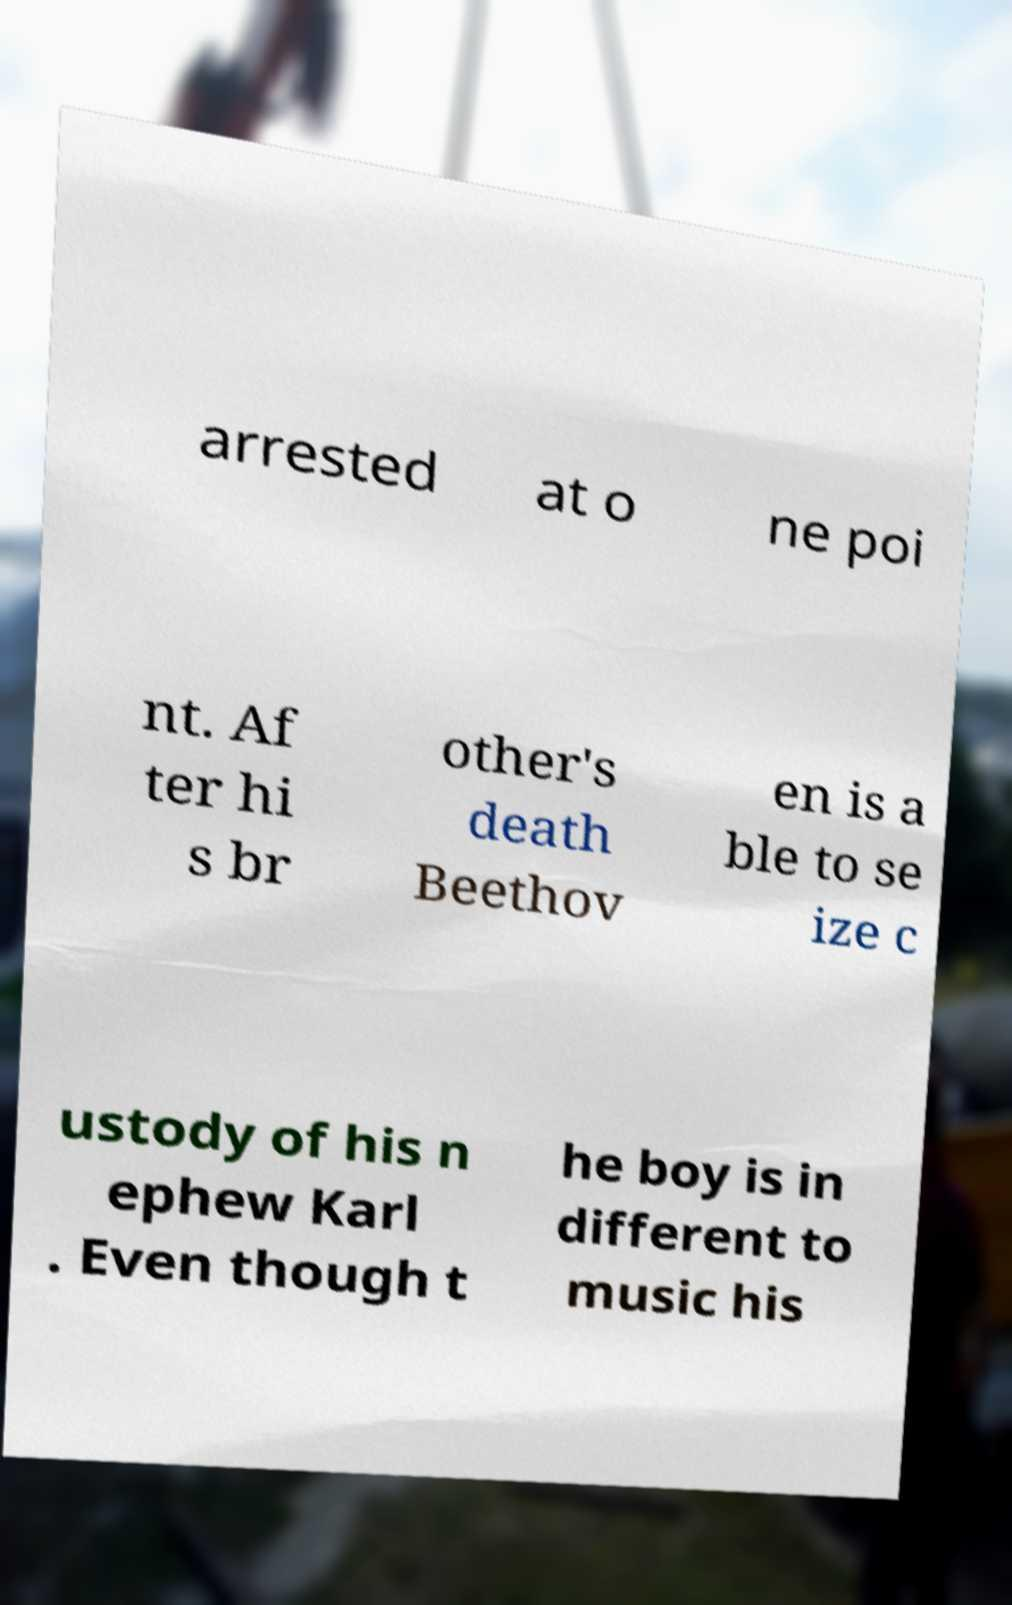Please identify and transcribe the text found in this image. arrested at o ne poi nt. Af ter hi s br other's death Beethov en is a ble to se ize c ustody of his n ephew Karl . Even though t he boy is in different to music his 